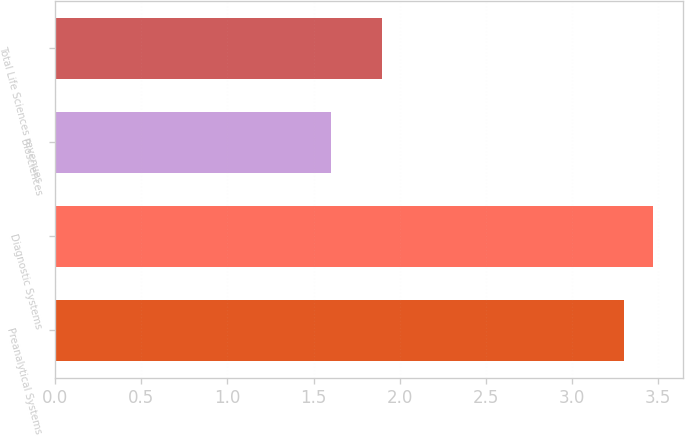<chart> <loc_0><loc_0><loc_500><loc_500><bar_chart><fcel>Preanalytical Systems<fcel>Diagnostic Systems<fcel>Biosciences<fcel>Total Life Sciences revenues<nl><fcel>3.3<fcel>3.47<fcel>1.6<fcel>1.9<nl></chart> 